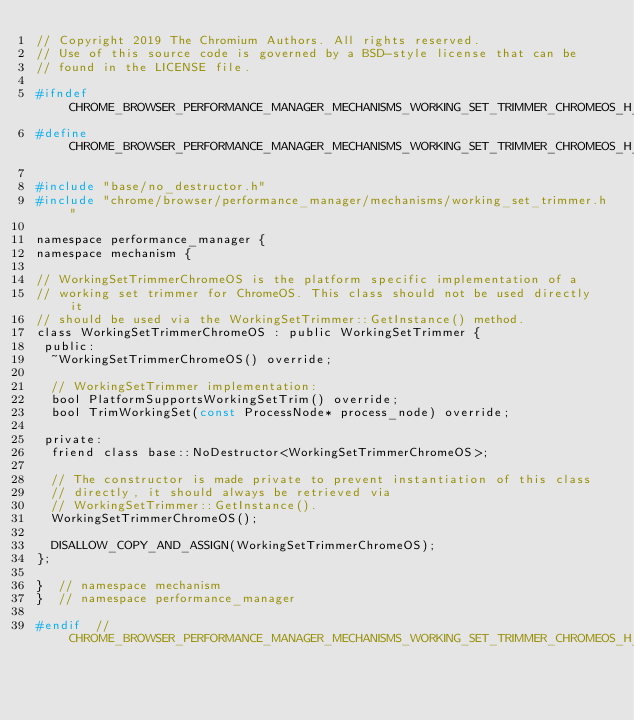<code> <loc_0><loc_0><loc_500><loc_500><_C_>// Copyright 2019 The Chromium Authors. All rights reserved.
// Use of this source code is governed by a BSD-style license that can be
// found in the LICENSE file.

#ifndef CHROME_BROWSER_PERFORMANCE_MANAGER_MECHANISMS_WORKING_SET_TRIMMER_CHROMEOS_H_
#define CHROME_BROWSER_PERFORMANCE_MANAGER_MECHANISMS_WORKING_SET_TRIMMER_CHROMEOS_H_

#include "base/no_destructor.h"
#include "chrome/browser/performance_manager/mechanisms/working_set_trimmer.h"

namespace performance_manager {
namespace mechanism {

// WorkingSetTrimmerChromeOS is the platform specific implementation of a
// working set trimmer for ChromeOS. This class should not be used directly it
// should be used via the WorkingSetTrimmer::GetInstance() method.
class WorkingSetTrimmerChromeOS : public WorkingSetTrimmer {
 public:
  ~WorkingSetTrimmerChromeOS() override;

  // WorkingSetTrimmer implementation:
  bool PlatformSupportsWorkingSetTrim() override;
  bool TrimWorkingSet(const ProcessNode* process_node) override;

 private:
  friend class base::NoDestructor<WorkingSetTrimmerChromeOS>;

  // The constructor is made private to prevent instantiation of this class
  // directly, it should always be retrieved via
  // WorkingSetTrimmer::GetInstance().
  WorkingSetTrimmerChromeOS();

  DISALLOW_COPY_AND_ASSIGN(WorkingSetTrimmerChromeOS);
};

}  // namespace mechanism
}  // namespace performance_manager

#endif  // CHROME_BROWSER_PERFORMANCE_MANAGER_MECHANISMS_WORKING_SET_TRIMMER_CHROMEOS_H_
</code> 